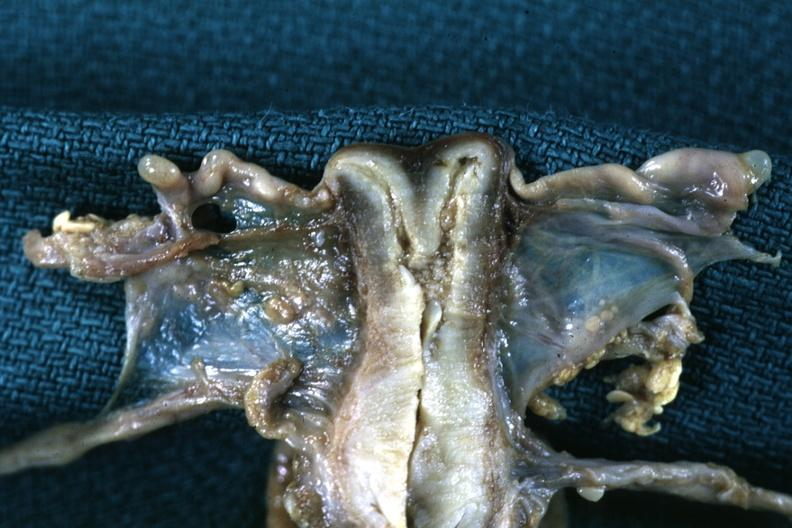s cervix duplication present?
Answer the question using a single word or phrase. Yes 